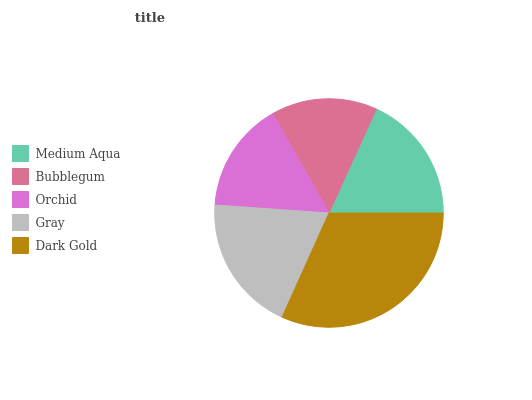Is Bubblegum the minimum?
Answer yes or no. Yes. Is Dark Gold the maximum?
Answer yes or no. Yes. Is Orchid the minimum?
Answer yes or no. No. Is Orchid the maximum?
Answer yes or no. No. Is Orchid greater than Bubblegum?
Answer yes or no. Yes. Is Bubblegum less than Orchid?
Answer yes or no. Yes. Is Bubblegum greater than Orchid?
Answer yes or no. No. Is Orchid less than Bubblegum?
Answer yes or no. No. Is Medium Aqua the high median?
Answer yes or no. Yes. Is Medium Aqua the low median?
Answer yes or no. Yes. Is Gray the high median?
Answer yes or no. No. Is Gray the low median?
Answer yes or no. No. 